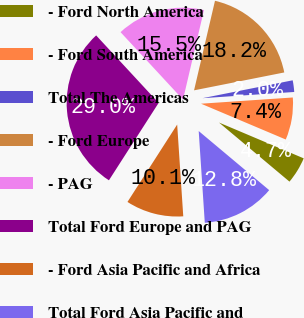<chart> <loc_0><loc_0><loc_500><loc_500><pie_chart><fcel>- Ford North America<fcel>- Ford South America<fcel>Total The Americas<fcel>- Ford Europe<fcel>- PAG<fcel>Total Ford Europe and PAG<fcel>- Ford Asia Pacific and Africa<fcel>Total Ford Asia Pacific and<nl><fcel>4.74%<fcel>7.44%<fcel>2.04%<fcel>18.23%<fcel>15.54%<fcel>29.03%<fcel>10.14%<fcel>12.84%<nl></chart> 